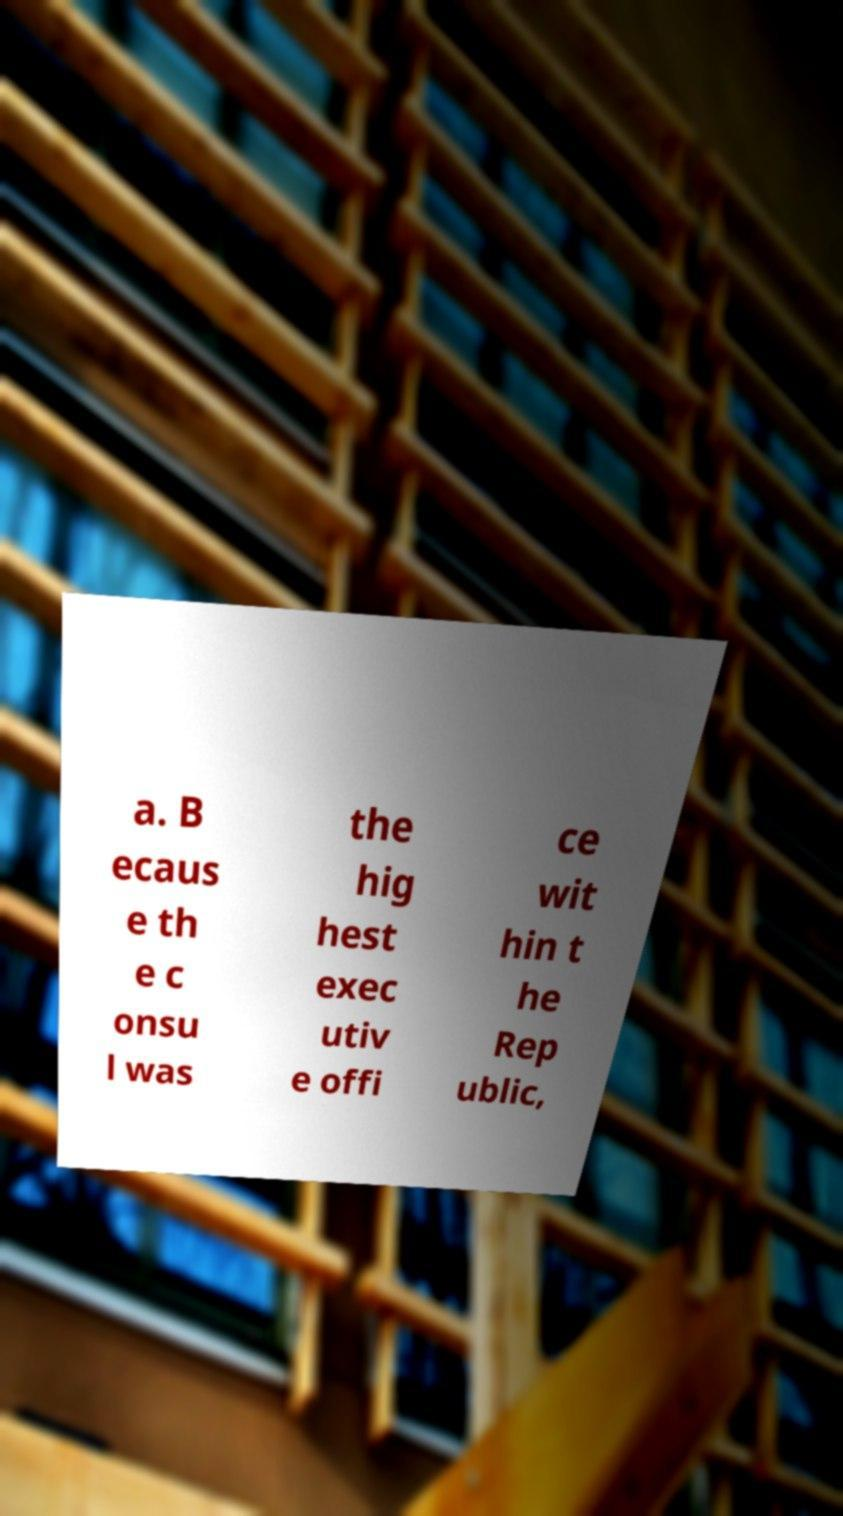For documentation purposes, I need the text within this image transcribed. Could you provide that? a. B ecaus e th e c onsu l was the hig hest exec utiv e offi ce wit hin t he Rep ublic, 